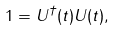<formula> <loc_0><loc_0><loc_500><loc_500>1 = U ^ { \dagger } ( t ) U ( t ) ,</formula> 